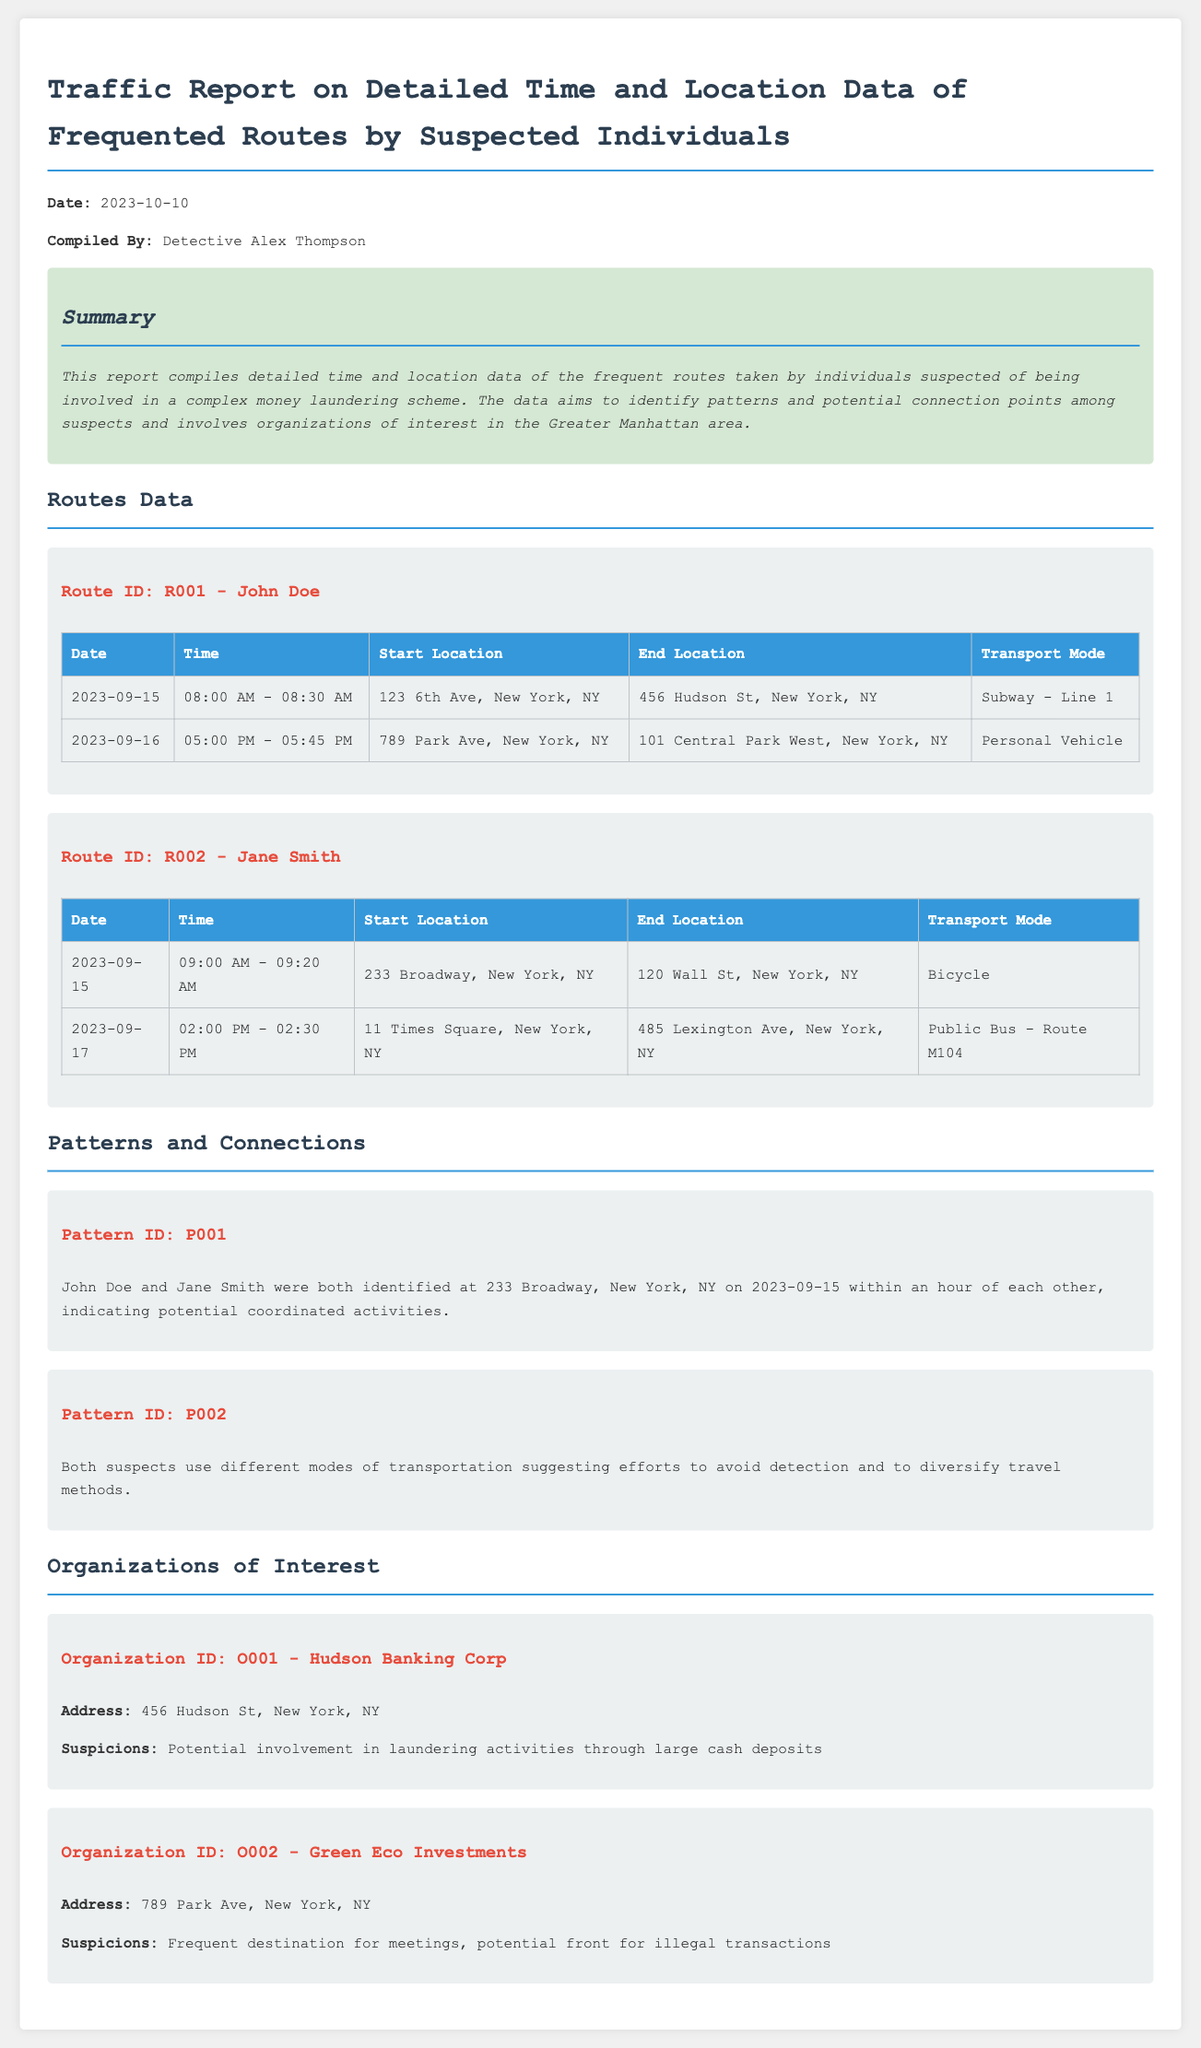what is the date of the report? The date mentioned in the report is located at the beginning, indicating when the report was compiled.
Answer: 2023-10-10 who compiled the report? The individual responsible for compiling the report is explicitly stated in the document.
Answer: Detective Alex Thompson which mode of transport did John Doe use on 2023-09-16? The report details the transport mode used by John Doe on that specific date.
Answer: Personal Vehicle what was the start location for Jane Smith on 2023-09-15? The document outlines the start location for Jane Smith on that date within the routes section.
Answer: 233 Broadway, New York, NY how long did John Doe travel on 2023-09-15? The duration of John Doe's travel is derived by analyzing the time taken from the start to end location.
Answer: 30 minutes what does Pattern ID P001 indicate? This pattern connects John Doe and Jane Smith's presence at the same location within the same timeframe, highlighting a potential link.
Answer: Coordinated activities what is the suspicion regarding Hudson Banking Corp? The report describes the nature of suspicions surrounding this organization based on its activities.
Answer: Potential involvement in laundering activities through large cash deposits how many routes are documented for Jane Smith? The report specifies the number of routes taken by Jane Smith in the routes data section.
Answer: 2 routes 